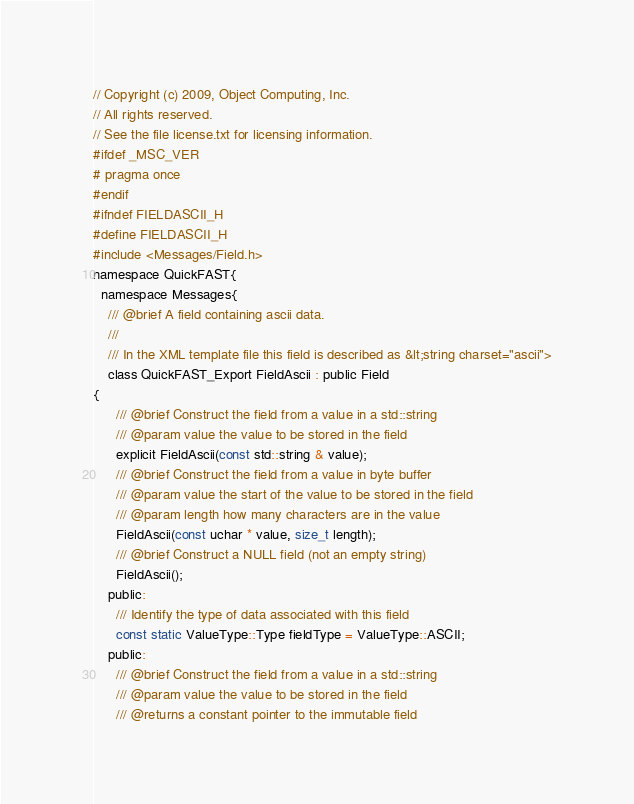Convert code to text. <code><loc_0><loc_0><loc_500><loc_500><_C_>// Copyright (c) 2009, Object Computing, Inc.
// All rights reserved.
// See the file license.txt for licensing information.
#ifdef _MSC_VER
# pragma once
#endif
#ifndef FIELDASCII_H
#define FIELDASCII_H
#include <Messages/Field.h>
namespace QuickFAST{
  namespace Messages{
    /// @brief A field containing ascii data.
    ///
    /// In the XML template file this field is described as &lt;string charset="ascii">
    class QuickFAST_Export FieldAscii : public Field
{
      /// @brief Construct the field from a value in a std::string
      /// @param value the value to be stored in the field
      explicit FieldAscii(const std::string & value);
      /// @brief Construct the field from a value in byte buffer
      /// @param value the start of the value to be stored in the field
      /// @param length how many characters are in the value
      FieldAscii(const uchar * value, size_t length);
      /// @brief Construct a NULL field (not an empty string)
      FieldAscii();
    public:
      /// Identify the type of data associated with this field
      const static ValueType::Type fieldType = ValueType::ASCII;
    public:
      /// @brief Construct the field from a value in a std::string
      /// @param value the value to be stored in the field
      /// @returns a constant pointer to the immutable field</code> 